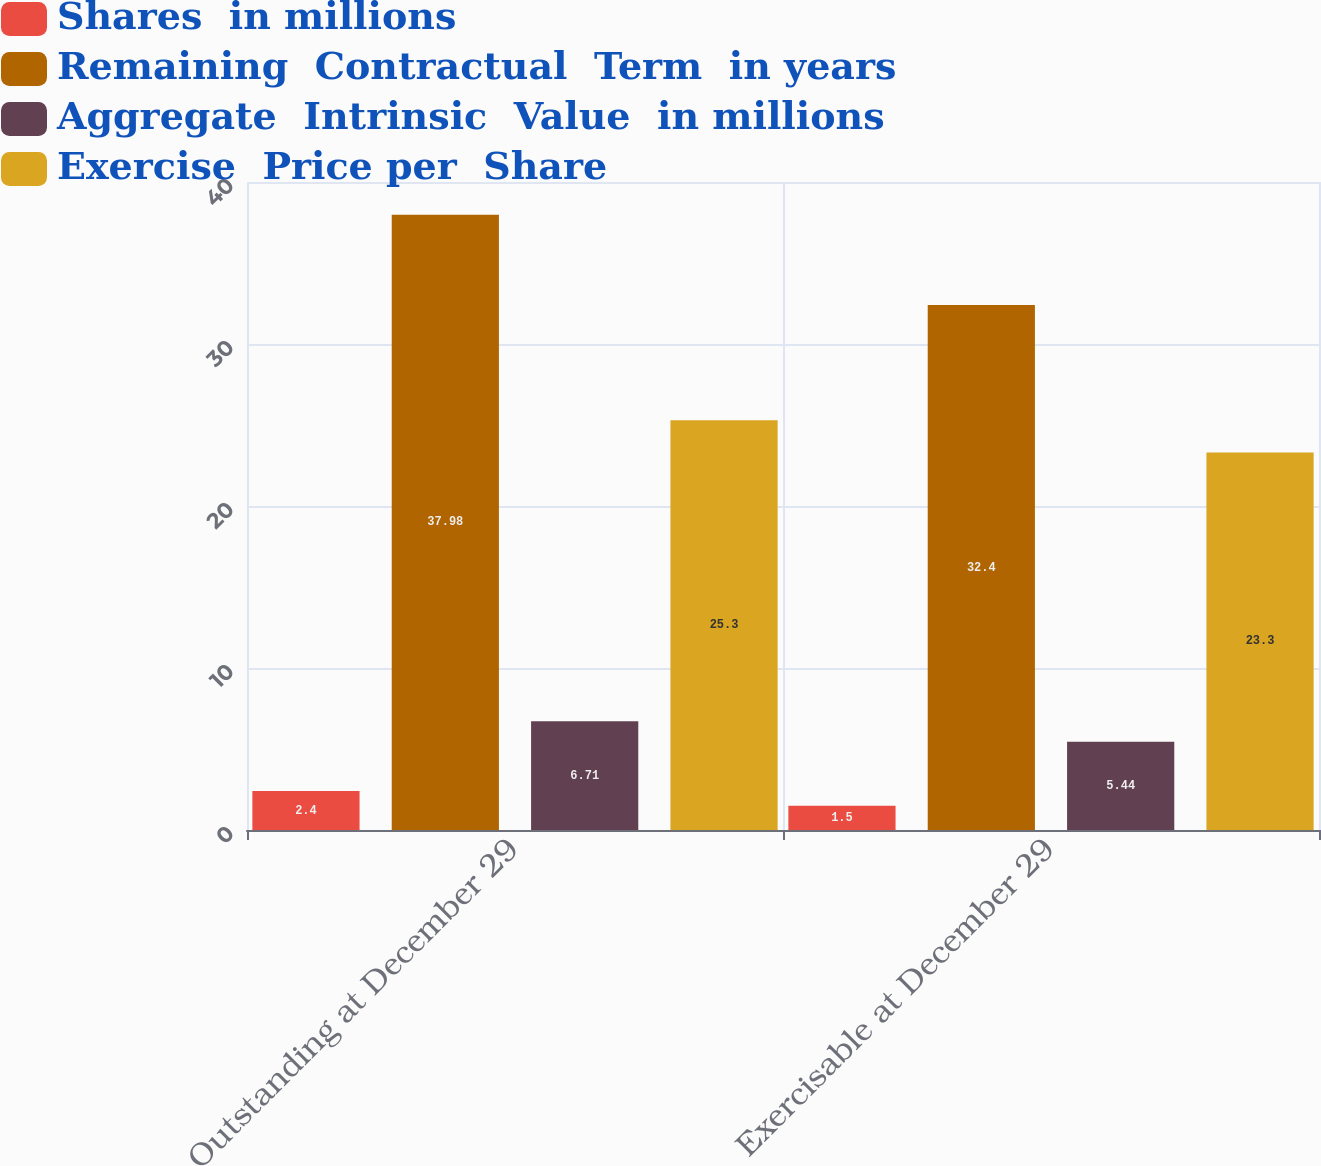Convert chart. <chart><loc_0><loc_0><loc_500><loc_500><stacked_bar_chart><ecel><fcel>Outstanding at December 29<fcel>Exercisable at December 29<nl><fcel>Shares  in millions<fcel>2.4<fcel>1.5<nl><fcel>Remaining  Contractual  Term  in years<fcel>37.98<fcel>32.4<nl><fcel>Aggregate  Intrinsic  Value  in millions<fcel>6.71<fcel>5.44<nl><fcel>Exercise  Price per  Share<fcel>25.3<fcel>23.3<nl></chart> 